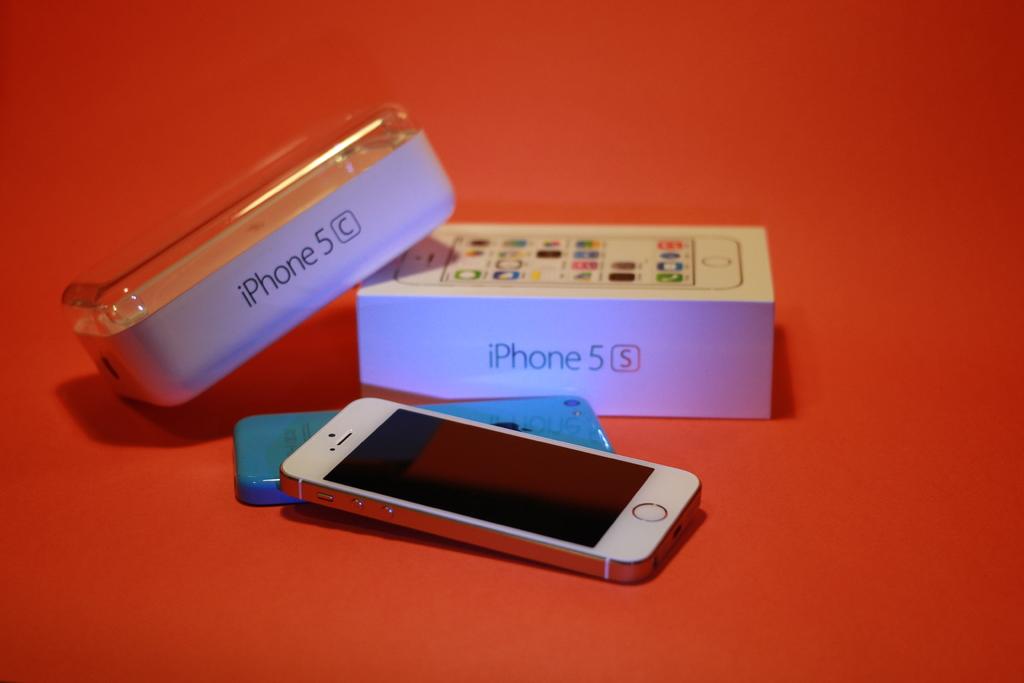Which iphone is that?
Provide a short and direct response. 5. 